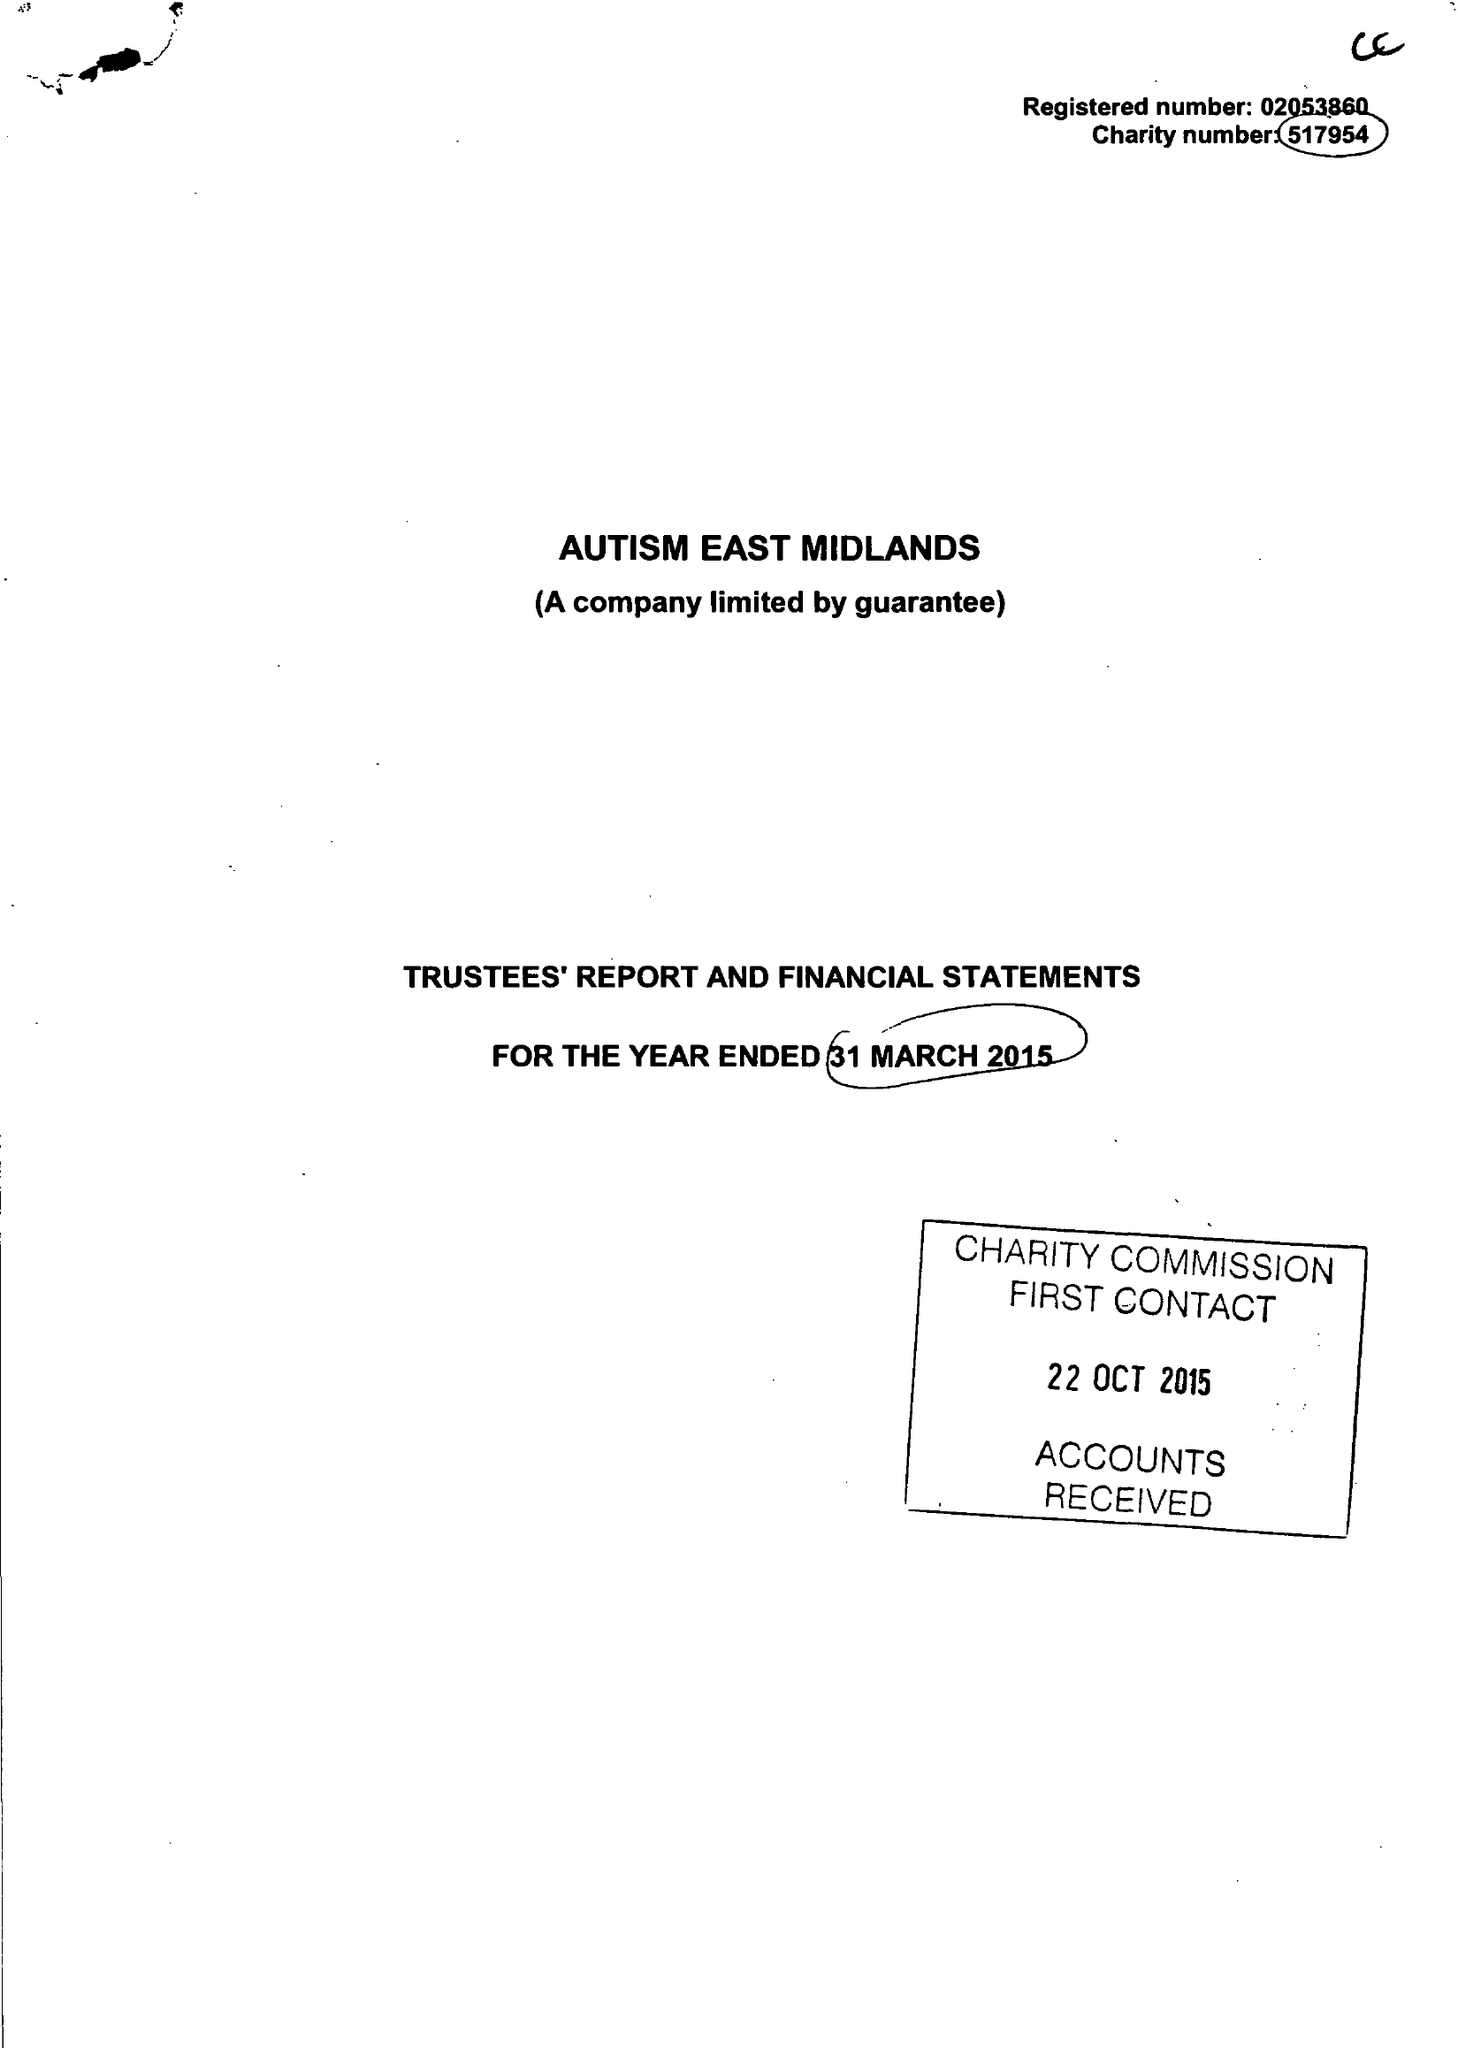What is the value for the address__post_town?
Answer the question using a single word or phrase. WORKSOP 